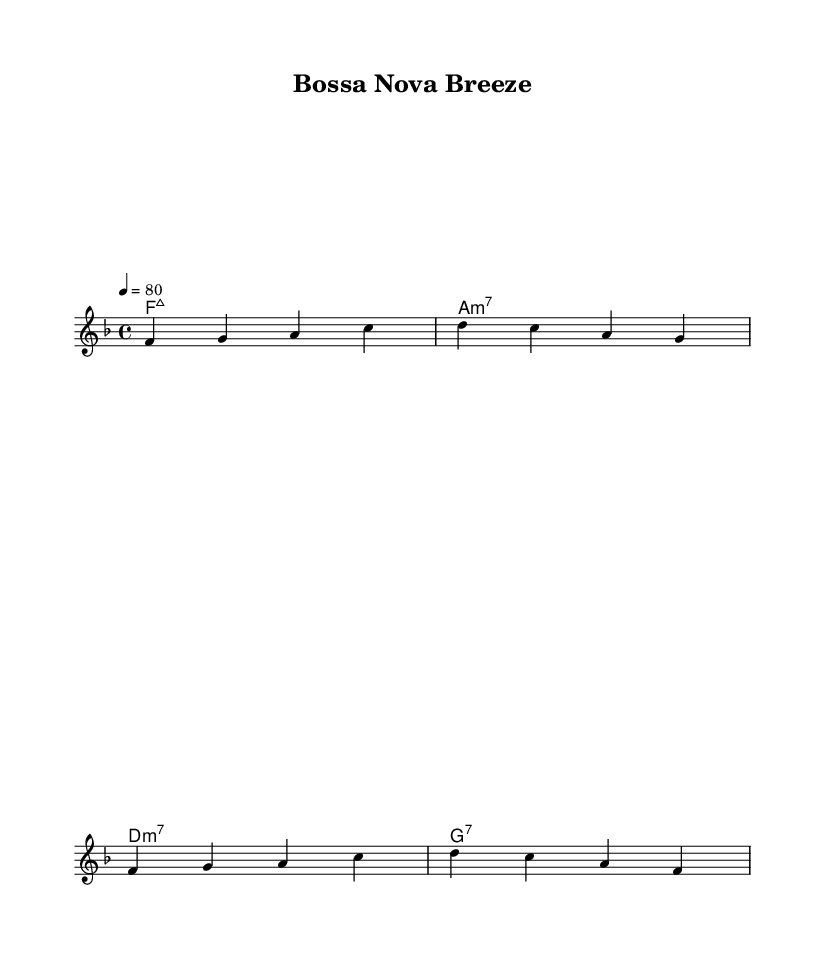What is the key signature of this music? The key signature is indicated at the beginning of the staff and shows one flat, which corresponds to the key of F major.
Answer: F major What is the time signature of the piece? The time signature is found right after the key signature, represented by the numbers 4 over 4, indicating that there are four beats per measure and the quarter note receives one beat.
Answer: 4/4 What is the tempo marking for this music? The tempo marking is indicated in the score as "4 = 80," meaning the quarter note is set to 80 beats per minute.
Answer: 80 How many measures are in the melody section? By counting the groups of notes separated by vertical lines (bar lines) in the melody part, we can see there are four measures present.
Answer: 4 What is the first chord played in the harmony? The first chord shown in the harmonies section is indicated as "f:maj7," which denotes a F major 7th chord.
Answer: F major 7 What is the chord progression of the first two measures? Analyzing the chords in the score reveals that the first two measures feature "f:maj7" in the first measure and "a:m7" in the second measure, creating a specific progression.
Answer: F major 7 to A minor 7 What kind of music style does this piece represent? The overall characteristics, including the syncopated rhythm and soft melody typical of bossa nova, confirm that this piece belongs to the bossa nova genre.
Answer: Bossa nova 